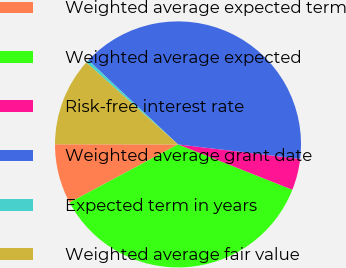<chart> <loc_0><loc_0><loc_500><loc_500><pie_chart><fcel>Weighted average expected term<fcel>Weighted average expected<fcel>Risk-free interest rate<fcel>Weighted average grant date<fcel>Expected term in years<fcel>Weighted average fair value<nl><fcel>7.86%<fcel>36.15%<fcel>4.13%<fcel>39.88%<fcel>0.4%<fcel>11.58%<nl></chart> 